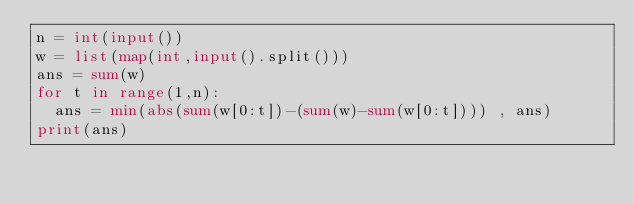Convert code to text. <code><loc_0><loc_0><loc_500><loc_500><_Python_>n = int(input())
w = list(map(int,input().split()))
ans = sum(w)
for t in range(1,n):
  ans = min(abs(sum(w[0:t])-(sum(w)-sum(w[0:t]))) , ans)
print(ans)</code> 